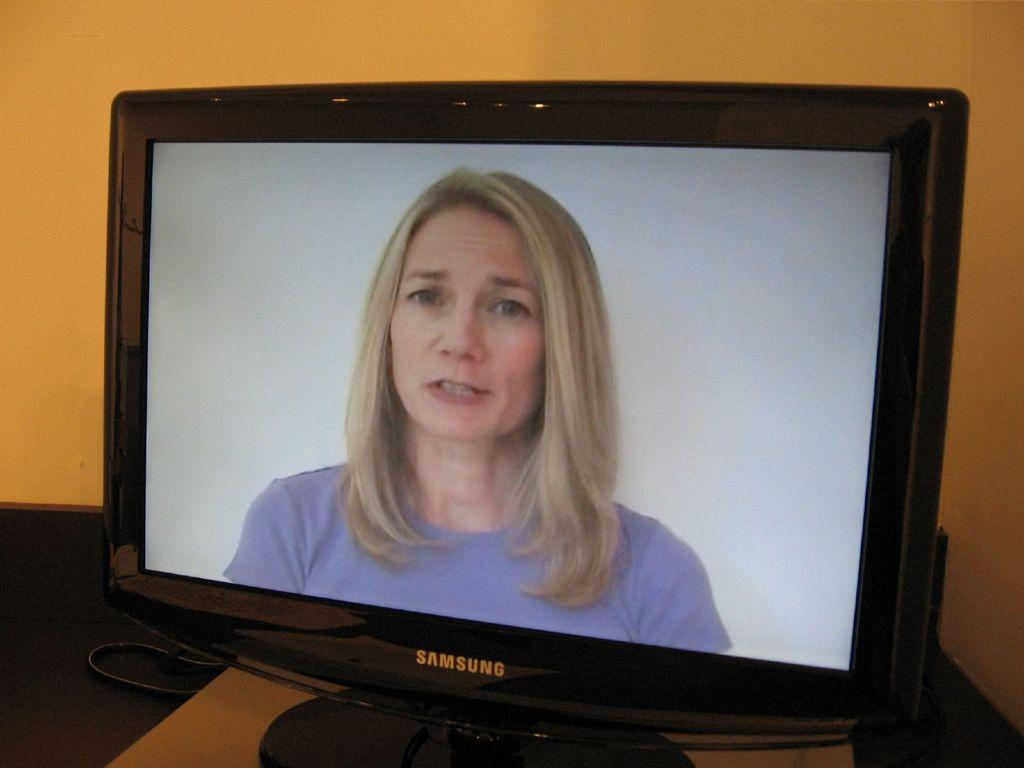<image>
Present a compact description of the photo's key features. A woman in a purple shirt is on the the screen of the Samsung monitor. 